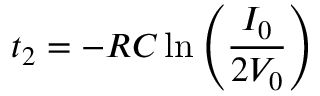<formula> <loc_0><loc_0><loc_500><loc_500>t _ { 2 } = - R C \ln { \left ( \frac { I _ { 0 } } { 2 V _ { 0 } } \right ) }</formula> 